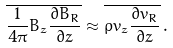<formula> <loc_0><loc_0><loc_500><loc_500>\overline { \frac { 1 } { 4 \pi } B _ { z } \frac { \partial B _ { R } } { \partial z } } \approx \overline { \varrho v _ { z } \frac { \partial v _ { R } } { \partial z } } \, .</formula> 